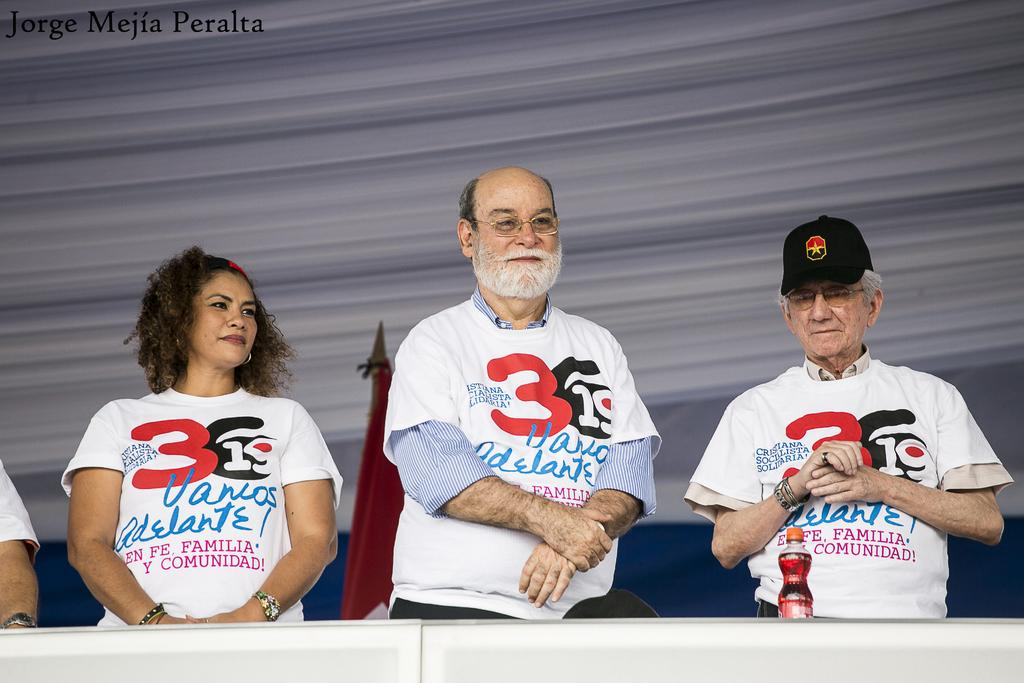<image>
Provide a brief description of the given image. a man has the number 3 on his shirt 